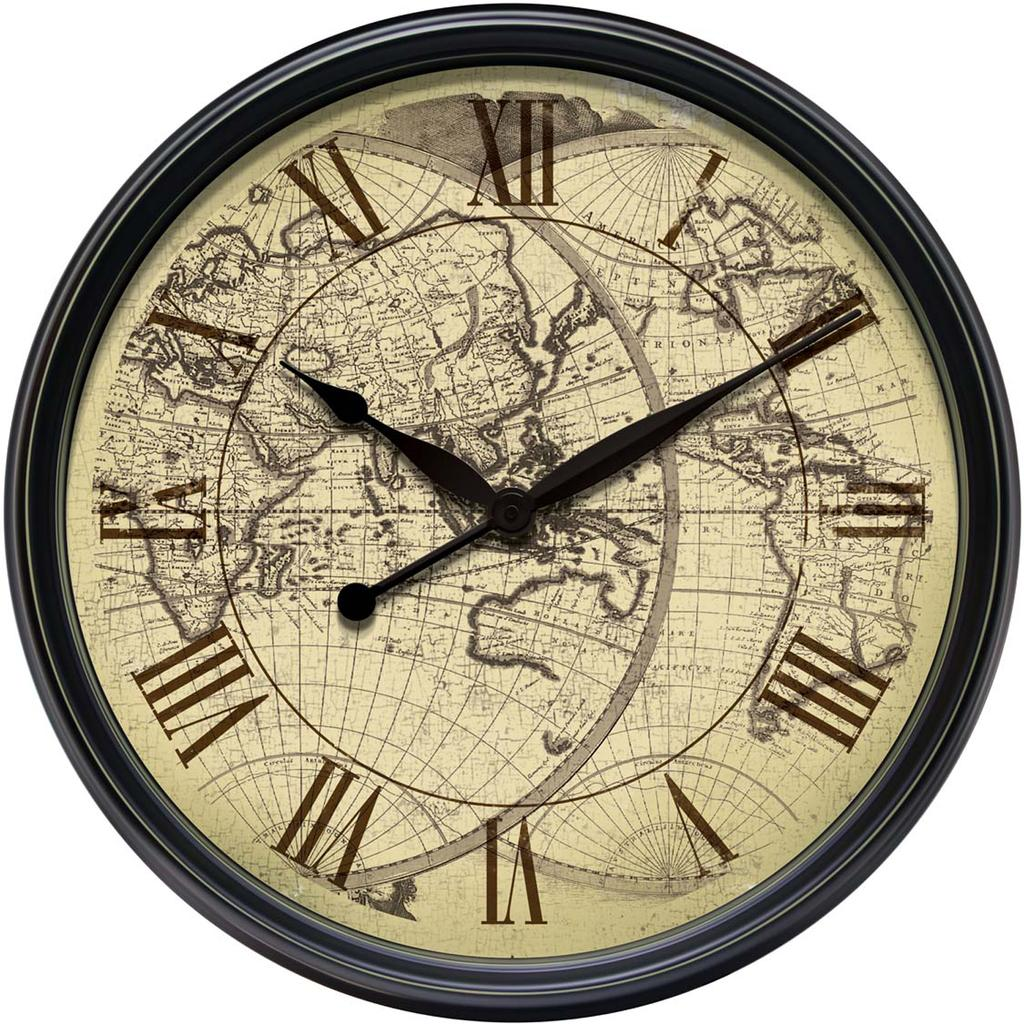What object in the picture indicates the time? There is a clock in the picture. How are the numbers displayed on the clock? The clock has roman numbers. What additional feature is present on the clock? The clock has a world map. What is the color of the background in the image? The background of the image is white. Can you see a frog hopping on the world map in the image? There is no frog present in the image, and the world map is a feature of the clock, not a separate object. 